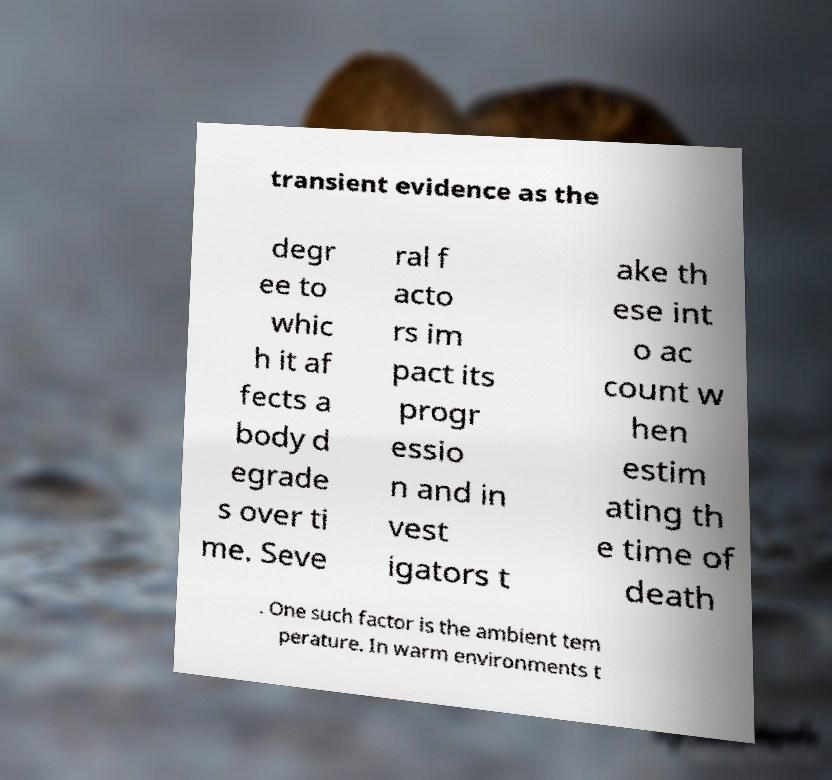Can you accurately transcribe the text from the provided image for me? transient evidence as the degr ee to whic h it af fects a body d egrade s over ti me. Seve ral f acto rs im pact its progr essio n and in vest igators t ake th ese int o ac count w hen estim ating th e time of death . One such factor is the ambient tem perature. In warm environments t 